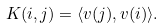Convert formula to latex. <formula><loc_0><loc_0><loc_500><loc_500>K ( i , j ) = \langle v ( j ) , v ( i ) \rangle .</formula> 